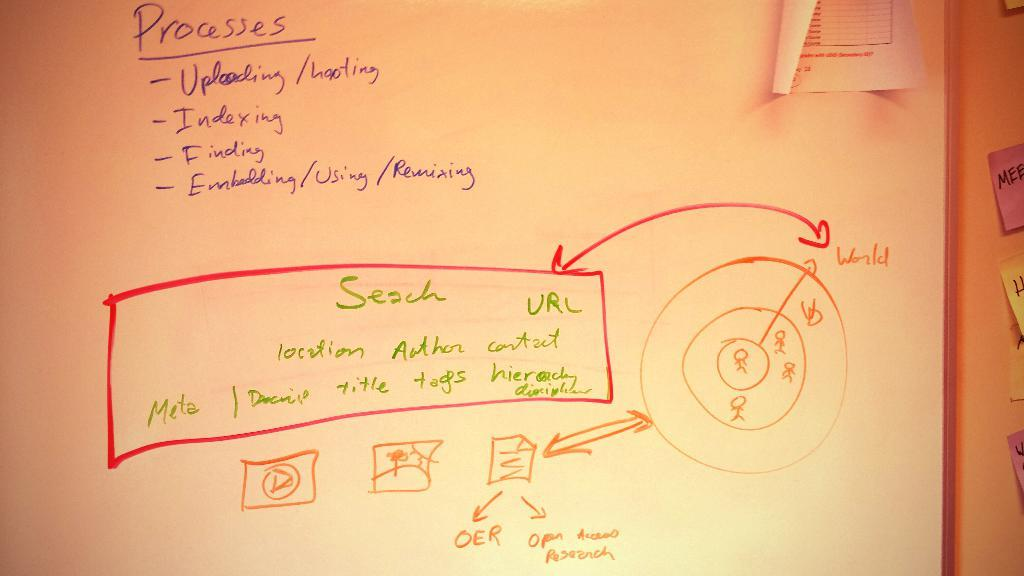<image>
Provide a brief description of the given image. White board with a diagram and a list that tells you the processes 